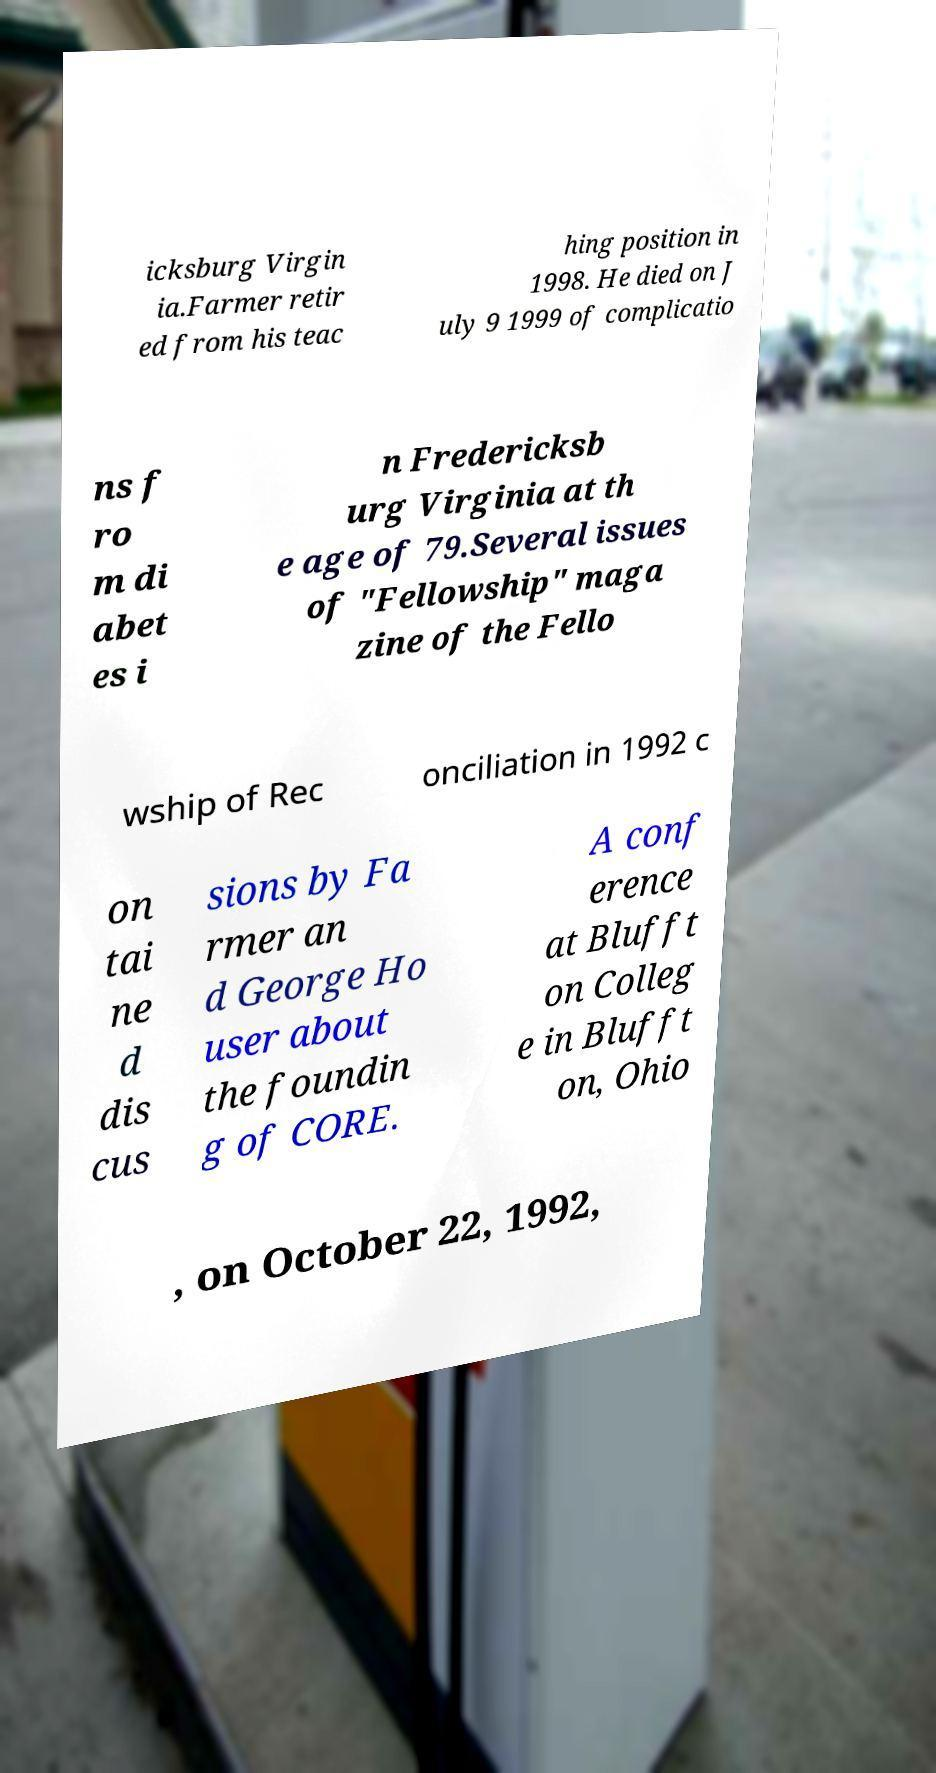I need the written content from this picture converted into text. Can you do that? icksburg Virgin ia.Farmer retir ed from his teac hing position in 1998. He died on J uly 9 1999 of complicatio ns f ro m di abet es i n Fredericksb urg Virginia at th e age of 79.Several issues of "Fellowship" maga zine of the Fello wship of Rec onciliation in 1992 c on tai ne d dis cus sions by Fa rmer an d George Ho user about the foundin g of CORE. A conf erence at Blufft on Colleg e in Blufft on, Ohio , on October 22, 1992, 